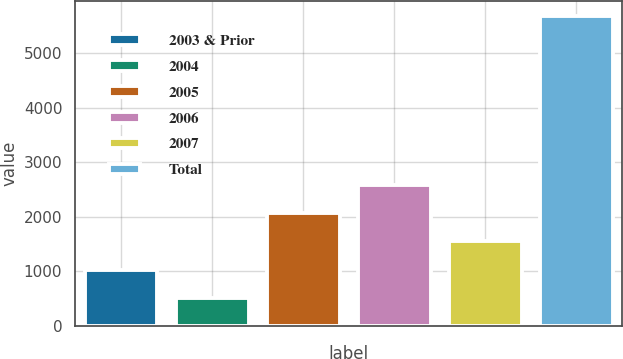Convert chart. <chart><loc_0><loc_0><loc_500><loc_500><bar_chart><fcel>2003 & Prior<fcel>2004<fcel>2005<fcel>2006<fcel>2007<fcel>Total<nl><fcel>1031.3<fcel>514<fcel>2065.9<fcel>2583.2<fcel>1548.6<fcel>5687<nl></chart> 